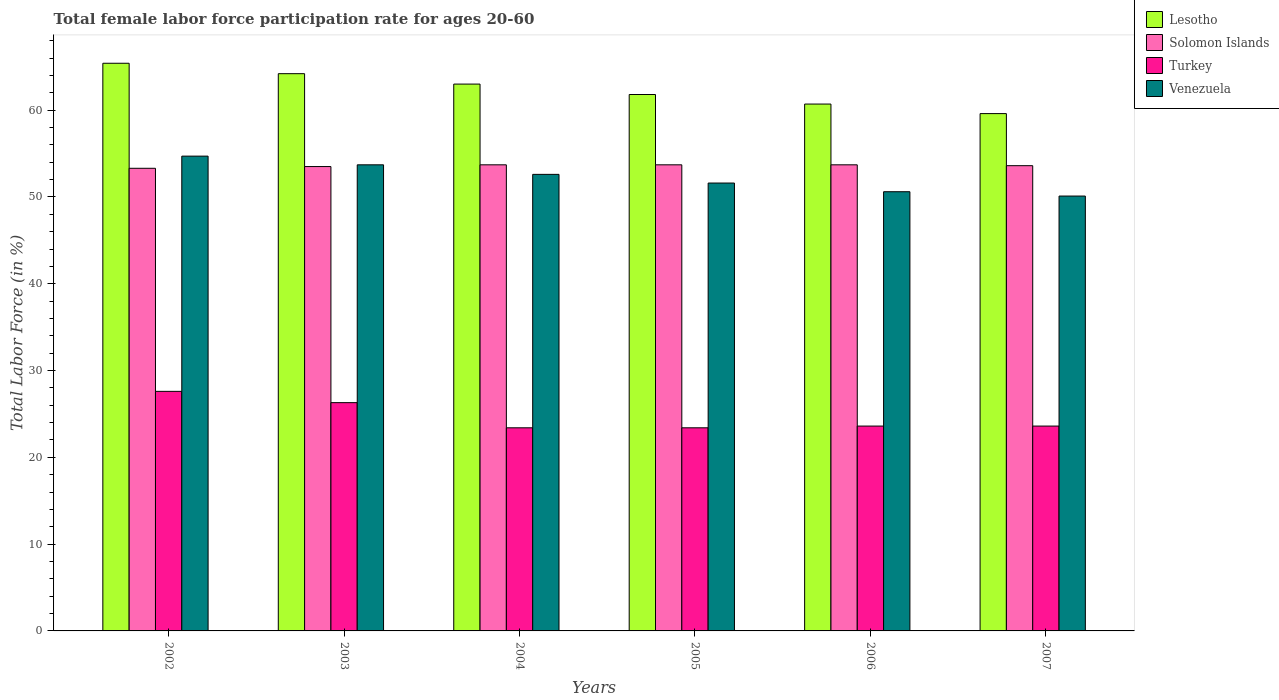How many different coloured bars are there?
Your answer should be compact. 4. How many groups of bars are there?
Offer a very short reply. 6. How many bars are there on the 2nd tick from the right?
Make the answer very short. 4. What is the label of the 2nd group of bars from the left?
Make the answer very short. 2003. What is the female labor force participation rate in Solomon Islands in 2005?
Offer a very short reply. 53.7. Across all years, what is the maximum female labor force participation rate in Turkey?
Make the answer very short. 27.6. Across all years, what is the minimum female labor force participation rate in Venezuela?
Make the answer very short. 50.1. In which year was the female labor force participation rate in Venezuela maximum?
Your answer should be compact. 2002. In which year was the female labor force participation rate in Solomon Islands minimum?
Your answer should be compact. 2002. What is the total female labor force participation rate in Venezuela in the graph?
Provide a succinct answer. 313.3. What is the difference between the female labor force participation rate in Lesotho in 2004 and that in 2005?
Keep it short and to the point. 1.2. What is the difference between the female labor force participation rate in Turkey in 2005 and the female labor force participation rate in Lesotho in 2006?
Your answer should be very brief. -37.3. What is the average female labor force participation rate in Solomon Islands per year?
Ensure brevity in your answer.  53.58. In the year 2005, what is the difference between the female labor force participation rate in Venezuela and female labor force participation rate in Lesotho?
Offer a terse response. -10.2. What is the ratio of the female labor force participation rate in Lesotho in 2004 to that in 2005?
Your response must be concise. 1.02. Is the female labor force participation rate in Turkey in 2002 less than that in 2006?
Make the answer very short. No. Is the difference between the female labor force participation rate in Venezuela in 2004 and 2006 greater than the difference between the female labor force participation rate in Lesotho in 2004 and 2006?
Offer a terse response. No. What is the difference between the highest and the second highest female labor force participation rate in Lesotho?
Your answer should be compact. 1.2. What is the difference between the highest and the lowest female labor force participation rate in Solomon Islands?
Your answer should be compact. 0.4. In how many years, is the female labor force participation rate in Lesotho greater than the average female labor force participation rate in Lesotho taken over all years?
Provide a short and direct response. 3. Is the sum of the female labor force participation rate in Turkey in 2002 and 2003 greater than the maximum female labor force participation rate in Solomon Islands across all years?
Give a very brief answer. Yes. Is it the case that in every year, the sum of the female labor force participation rate in Solomon Islands and female labor force participation rate in Lesotho is greater than the sum of female labor force participation rate in Turkey and female labor force participation rate in Venezuela?
Provide a short and direct response. No. What does the 2nd bar from the left in 2003 represents?
Your response must be concise. Solomon Islands. What does the 1st bar from the right in 2002 represents?
Keep it short and to the point. Venezuela. Are all the bars in the graph horizontal?
Offer a terse response. No. What is the difference between two consecutive major ticks on the Y-axis?
Keep it short and to the point. 10. Are the values on the major ticks of Y-axis written in scientific E-notation?
Keep it short and to the point. No. Does the graph contain any zero values?
Make the answer very short. No. Does the graph contain grids?
Offer a terse response. No. Where does the legend appear in the graph?
Offer a very short reply. Top right. How are the legend labels stacked?
Your answer should be very brief. Vertical. What is the title of the graph?
Provide a succinct answer. Total female labor force participation rate for ages 20-60. What is the Total Labor Force (in %) of Lesotho in 2002?
Ensure brevity in your answer.  65.4. What is the Total Labor Force (in %) of Solomon Islands in 2002?
Ensure brevity in your answer.  53.3. What is the Total Labor Force (in %) of Turkey in 2002?
Your response must be concise. 27.6. What is the Total Labor Force (in %) in Venezuela in 2002?
Offer a terse response. 54.7. What is the Total Labor Force (in %) in Lesotho in 2003?
Your answer should be very brief. 64.2. What is the Total Labor Force (in %) of Solomon Islands in 2003?
Offer a terse response. 53.5. What is the Total Labor Force (in %) in Turkey in 2003?
Offer a terse response. 26.3. What is the Total Labor Force (in %) in Venezuela in 2003?
Make the answer very short. 53.7. What is the Total Labor Force (in %) of Solomon Islands in 2004?
Provide a succinct answer. 53.7. What is the Total Labor Force (in %) of Turkey in 2004?
Ensure brevity in your answer.  23.4. What is the Total Labor Force (in %) in Venezuela in 2004?
Keep it short and to the point. 52.6. What is the Total Labor Force (in %) of Lesotho in 2005?
Provide a short and direct response. 61.8. What is the Total Labor Force (in %) in Solomon Islands in 2005?
Provide a succinct answer. 53.7. What is the Total Labor Force (in %) of Turkey in 2005?
Provide a succinct answer. 23.4. What is the Total Labor Force (in %) of Venezuela in 2005?
Keep it short and to the point. 51.6. What is the Total Labor Force (in %) in Lesotho in 2006?
Offer a very short reply. 60.7. What is the Total Labor Force (in %) in Solomon Islands in 2006?
Make the answer very short. 53.7. What is the Total Labor Force (in %) of Turkey in 2006?
Offer a very short reply. 23.6. What is the Total Labor Force (in %) in Venezuela in 2006?
Provide a short and direct response. 50.6. What is the Total Labor Force (in %) in Lesotho in 2007?
Keep it short and to the point. 59.6. What is the Total Labor Force (in %) of Solomon Islands in 2007?
Offer a terse response. 53.6. What is the Total Labor Force (in %) in Turkey in 2007?
Keep it short and to the point. 23.6. What is the Total Labor Force (in %) in Venezuela in 2007?
Provide a succinct answer. 50.1. Across all years, what is the maximum Total Labor Force (in %) in Lesotho?
Provide a succinct answer. 65.4. Across all years, what is the maximum Total Labor Force (in %) in Solomon Islands?
Give a very brief answer. 53.7. Across all years, what is the maximum Total Labor Force (in %) of Turkey?
Keep it short and to the point. 27.6. Across all years, what is the maximum Total Labor Force (in %) of Venezuela?
Keep it short and to the point. 54.7. Across all years, what is the minimum Total Labor Force (in %) in Lesotho?
Offer a terse response. 59.6. Across all years, what is the minimum Total Labor Force (in %) of Solomon Islands?
Offer a very short reply. 53.3. Across all years, what is the minimum Total Labor Force (in %) of Turkey?
Your response must be concise. 23.4. Across all years, what is the minimum Total Labor Force (in %) of Venezuela?
Offer a terse response. 50.1. What is the total Total Labor Force (in %) in Lesotho in the graph?
Offer a very short reply. 374.7. What is the total Total Labor Force (in %) of Solomon Islands in the graph?
Offer a very short reply. 321.5. What is the total Total Labor Force (in %) of Turkey in the graph?
Give a very brief answer. 147.9. What is the total Total Labor Force (in %) of Venezuela in the graph?
Keep it short and to the point. 313.3. What is the difference between the Total Labor Force (in %) of Lesotho in 2002 and that in 2003?
Make the answer very short. 1.2. What is the difference between the Total Labor Force (in %) of Lesotho in 2002 and that in 2004?
Offer a very short reply. 2.4. What is the difference between the Total Labor Force (in %) in Solomon Islands in 2002 and that in 2004?
Make the answer very short. -0.4. What is the difference between the Total Labor Force (in %) of Turkey in 2002 and that in 2004?
Offer a very short reply. 4.2. What is the difference between the Total Labor Force (in %) in Solomon Islands in 2002 and that in 2005?
Ensure brevity in your answer.  -0.4. What is the difference between the Total Labor Force (in %) in Lesotho in 2002 and that in 2006?
Give a very brief answer. 4.7. What is the difference between the Total Labor Force (in %) of Solomon Islands in 2002 and that in 2006?
Offer a terse response. -0.4. What is the difference between the Total Labor Force (in %) of Venezuela in 2002 and that in 2006?
Your response must be concise. 4.1. What is the difference between the Total Labor Force (in %) of Lesotho in 2002 and that in 2007?
Offer a very short reply. 5.8. What is the difference between the Total Labor Force (in %) in Solomon Islands in 2003 and that in 2004?
Give a very brief answer. -0.2. What is the difference between the Total Labor Force (in %) in Turkey in 2003 and that in 2004?
Make the answer very short. 2.9. What is the difference between the Total Labor Force (in %) in Venezuela in 2003 and that in 2004?
Give a very brief answer. 1.1. What is the difference between the Total Labor Force (in %) in Lesotho in 2003 and that in 2005?
Make the answer very short. 2.4. What is the difference between the Total Labor Force (in %) in Turkey in 2003 and that in 2006?
Provide a short and direct response. 2.7. What is the difference between the Total Labor Force (in %) of Solomon Islands in 2003 and that in 2007?
Keep it short and to the point. -0.1. What is the difference between the Total Labor Force (in %) in Venezuela in 2003 and that in 2007?
Provide a short and direct response. 3.6. What is the difference between the Total Labor Force (in %) in Turkey in 2004 and that in 2005?
Offer a very short reply. 0. What is the difference between the Total Labor Force (in %) in Solomon Islands in 2004 and that in 2006?
Offer a terse response. 0. What is the difference between the Total Labor Force (in %) in Turkey in 2004 and that in 2006?
Ensure brevity in your answer.  -0.2. What is the difference between the Total Labor Force (in %) of Venezuela in 2004 and that in 2007?
Your answer should be very brief. 2.5. What is the difference between the Total Labor Force (in %) in Lesotho in 2005 and that in 2006?
Provide a succinct answer. 1.1. What is the difference between the Total Labor Force (in %) in Turkey in 2005 and that in 2006?
Your answer should be very brief. -0.2. What is the difference between the Total Labor Force (in %) in Venezuela in 2005 and that in 2006?
Offer a terse response. 1. What is the difference between the Total Labor Force (in %) in Lesotho in 2005 and that in 2007?
Offer a terse response. 2.2. What is the difference between the Total Labor Force (in %) of Turkey in 2005 and that in 2007?
Keep it short and to the point. -0.2. What is the difference between the Total Labor Force (in %) of Venezuela in 2005 and that in 2007?
Your answer should be very brief. 1.5. What is the difference between the Total Labor Force (in %) of Lesotho in 2006 and that in 2007?
Give a very brief answer. 1.1. What is the difference between the Total Labor Force (in %) of Turkey in 2006 and that in 2007?
Provide a short and direct response. 0. What is the difference between the Total Labor Force (in %) of Venezuela in 2006 and that in 2007?
Offer a very short reply. 0.5. What is the difference between the Total Labor Force (in %) in Lesotho in 2002 and the Total Labor Force (in %) in Turkey in 2003?
Offer a terse response. 39.1. What is the difference between the Total Labor Force (in %) in Lesotho in 2002 and the Total Labor Force (in %) in Venezuela in 2003?
Ensure brevity in your answer.  11.7. What is the difference between the Total Labor Force (in %) of Solomon Islands in 2002 and the Total Labor Force (in %) of Turkey in 2003?
Your answer should be very brief. 27. What is the difference between the Total Labor Force (in %) of Solomon Islands in 2002 and the Total Labor Force (in %) of Venezuela in 2003?
Give a very brief answer. -0.4. What is the difference between the Total Labor Force (in %) of Turkey in 2002 and the Total Labor Force (in %) of Venezuela in 2003?
Provide a succinct answer. -26.1. What is the difference between the Total Labor Force (in %) of Solomon Islands in 2002 and the Total Labor Force (in %) of Turkey in 2004?
Make the answer very short. 29.9. What is the difference between the Total Labor Force (in %) of Solomon Islands in 2002 and the Total Labor Force (in %) of Venezuela in 2004?
Provide a short and direct response. 0.7. What is the difference between the Total Labor Force (in %) of Lesotho in 2002 and the Total Labor Force (in %) of Turkey in 2005?
Your response must be concise. 42. What is the difference between the Total Labor Force (in %) in Solomon Islands in 2002 and the Total Labor Force (in %) in Turkey in 2005?
Provide a succinct answer. 29.9. What is the difference between the Total Labor Force (in %) of Lesotho in 2002 and the Total Labor Force (in %) of Turkey in 2006?
Keep it short and to the point. 41.8. What is the difference between the Total Labor Force (in %) of Solomon Islands in 2002 and the Total Labor Force (in %) of Turkey in 2006?
Provide a succinct answer. 29.7. What is the difference between the Total Labor Force (in %) in Lesotho in 2002 and the Total Labor Force (in %) in Solomon Islands in 2007?
Make the answer very short. 11.8. What is the difference between the Total Labor Force (in %) of Lesotho in 2002 and the Total Labor Force (in %) of Turkey in 2007?
Offer a very short reply. 41.8. What is the difference between the Total Labor Force (in %) of Solomon Islands in 2002 and the Total Labor Force (in %) of Turkey in 2007?
Ensure brevity in your answer.  29.7. What is the difference between the Total Labor Force (in %) in Solomon Islands in 2002 and the Total Labor Force (in %) in Venezuela in 2007?
Ensure brevity in your answer.  3.2. What is the difference between the Total Labor Force (in %) of Turkey in 2002 and the Total Labor Force (in %) of Venezuela in 2007?
Your answer should be compact. -22.5. What is the difference between the Total Labor Force (in %) of Lesotho in 2003 and the Total Labor Force (in %) of Solomon Islands in 2004?
Your response must be concise. 10.5. What is the difference between the Total Labor Force (in %) in Lesotho in 2003 and the Total Labor Force (in %) in Turkey in 2004?
Your response must be concise. 40.8. What is the difference between the Total Labor Force (in %) of Solomon Islands in 2003 and the Total Labor Force (in %) of Turkey in 2004?
Offer a very short reply. 30.1. What is the difference between the Total Labor Force (in %) of Turkey in 2003 and the Total Labor Force (in %) of Venezuela in 2004?
Give a very brief answer. -26.3. What is the difference between the Total Labor Force (in %) in Lesotho in 2003 and the Total Labor Force (in %) in Turkey in 2005?
Ensure brevity in your answer.  40.8. What is the difference between the Total Labor Force (in %) in Lesotho in 2003 and the Total Labor Force (in %) in Venezuela in 2005?
Ensure brevity in your answer.  12.6. What is the difference between the Total Labor Force (in %) in Solomon Islands in 2003 and the Total Labor Force (in %) in Turkey in 2005?
Provide a succinct answer. 30.1. What is the difference between the Total Labor Force (in %) of Turkey in 2003 and the Total Labor Force (in %) of Venezuela in 2005?
Give a very brief answer. -25.3. What is the difference between the Total Labor Force (in %) of Lesotho in 2003 and the Total Labor Force (in %) of Solomon Islands in 2006?
Offer a very short reply. 10.5. What is the difference between the Total Labor Force (in %) of Lesotho in 2003 and the Total Labor Force (in %) of Turkey in 2006?
Provide a short and direct response. 40.6. What is the difference between the Total Labor Force (in %) in Solomon Islands in 2003 and the Total Labor Force (in %) in Turkey in 2006?
Offer a terse response. 29.9. What is the difference between the Total Labor Force (in %) in Solomon Islands in 2003 and the Total Labor Force (in %) in Venezuela in 2006?
Make the answer very short. 2.9. What is the difference between the Total Labor Force (in %) of Turkey in 2003 and the Total Labor Force (in %) of Venezuela in 2006?
Provide a short and direct response. -24.3. What is the difference between the Total Labor Force (in %) in Lesotho in 2003 and the Total Labor Force (in %) in Solomon Islands in 2007?
Give a very brief answer. 10.6. What is the difference between the Total Labor Force (in %) in Lesotho in 2003 and the Total Labor Force (in %) in Turkey in 2007?
Give a very brief answer. 40.6. What is the difference between the Total Labor Force (in %) of Lesotho in 2003 and the Total Labor Force (in %) of Venezuela in 2007?
Give a very brief answer. 14.1. What is the difference between the Total Labor Force (in %) of Solomon Islands in 2003 and the Total Labor Force (in %) of Turkey in 2007?
Give a very brief answer. 29.9. What is the difference between the Total Labor Force (in %) in Solomon Islands in 2003 and the Total Labor Force (in %) in Venezuela in 2007?
Give a very brief answer. 3.4. What is the difference between the Total Labor Force (in %) of Turkey in 2003 and the Total Labor Force (in %) of Venezuela in 2007?
Provide a succinct answer. -23.8. What is the difference between the Total Labor Force (in %) in Lesotho in 2004 and the Total Labor Force (in %) in Turkey in 2005?
Make the answer very short. 39.6. What is the difference between the Total Labor Force (in %) of Lesotho in 2004 and the Total Labor Force (in %) of Venezuela in 2005?
Make the answer very short. 11.4. What is the difference between the Total Labor Force (in %) in Solomon Islands in 2004 and the Total Labor Force (in %) in Turkey in 2005?
Make the answer very short. 30.3. What is the difference between the Total Labor Force (in %) of Solomon Islands in 2004 and the Total Labor Force (in %) of Venezuela in 2005?
Offer a very short reply. 2.1. What is the difference between the Total Labor Force (in %) in Turkey in 2004 and the Total Labor Force (in %) in Venezuela in 2005?
Offer a very short reply. -28.2. What is the difference between the Total Labor Force (in %) of Lesotho in 2004 and the Total Labor Force (in %) of Solomon Islands in 2006?
Your response must be concise. 9.3. What is the difference between the Total Labor Force (in %) of Lesotho in 2004 and the Total Labor Force (in %) of Turkey in 2006?
Offer a terse response. 39.4. What is the difference between the Total Labor Force (in %) in Solomon Islands in 2004 and the Total Labor Force (in %) in Turkey in 2006?
Offer a very short reply. 30.1. What is the difference between the Total Labor Force (in %) in Turkey in 2004 and the Total Labor Force (in %) in Venezuela in 2006?
Offer a terse response. -27.2. What is the difference between the Total Labor Force (in %) in Lesotho in 2004 and the Total Labor Force (in %) in Turkey in 2007?
Your response must be concise. 39.4. What is the difference between the Total Labor Force (in %) in Solomon Islands in 2004 and the Total Labor Force (in %) in Turkey in 2007?
Give a very brief answer. 30.1. What is the difference between the Total Labor Force (in %) in Turkey in 2004 and the Total Labor Force (in %) in Venezuela in 2007?
Your answer should be very brief. -26.7. What is the difference between the Total Labor Force (in %) of Lesotho in 2005 and the Total Labor Force (in %) of Turkey in 2006?
Give a very brief answer. 38.2. What is the difference between the Total Labor Force (in %) of Lesotho in 2005 and the Total Labor Force (in %) of Venezuela in 2006?
Keep it short and to the point. 11.2. What is the difference between the Total Labor Force (in %) in Solomon Islands in 2005 and the Total Labor Force (in %) in Turkey in 2006?
Provide a short and direct response. 30.1. What is the difference between the Total Labor Force (in %) in Turkey in 2005 and the Total Labor Force (in %) in Venezuela in 2006?
Give a very brief answer. -27.2. What is the difference between the Total Labor Force (in %) of Lesotho in 2005 and the Total Labor Force (in %) of Solomon Islands in 2007?
Your response must be concise. 8.2. What is the difference between the Total Labor Force (in %) in Lesotho in 2005 and the Total Labor Force (in %) in Turkey in 2007?
Keep it short and to the point. 38.2. What is the difference between the Total Labor Force (in %) in Lesotho in 2005 and the Total Labor Force (in %) in Venezuela in 2007?
Keep it short and to the point. 11.7. What is the difference between the Total Labor Force (in %) of Solomon Islands in 2005 and the Total Labor Force (in %) of Turkey in 2007?
Your response must be concise. 30.1. What is the difference between the Total Labor Force (in %) of Solomon Islands in 2005 and the Total Labor Force (in %) of Venezuela in 2007?
Your response must be concise. 3.6. What is the difference between the Total Labor Force (in %) of Turkey in 2005 and the Total Labor Force (in %) of Venezuela in 2007?
Provide a short and direct response. -26.7. What is the difference between the Total Labor Force (in %) in Lesotho in 2006 and the Total Labor Force (in %) in Solomon Islands in 2007?
Make the answer very short. 7.1. What is the difference between the Total Labor Force (in %) in Lesotho in 2006 and the Total Labor Force (in %) in Turkey in 2007?
Make the answer very short. 37.1. What is the difference between the Total Labor Force (in %) in Solomon Islands in 2006 and the Total Labor Force (in %) in Turkey in 2007?
Make the answer very short. 30.1. What is the difference between the Total Labor Force (in %) of Solomon Islands in 2006 and the Total Labor Force (in %) of Venezuela in 2007?
Provide a short and direct response. 3.6. What is the difference between the Total Labor Force (in %) in Turkey in 2006 and the Total Labor Force (in %) in Venezuela in 2007?
Make the answer very short. -26.5. What is the average Total Labor Force (in %) of Lesotho per year?
Offer a terse response. 62.45. What is the average Total Labor Force (in %) in Solomon Islands per year?
Provide a short and direct response. 53.58. What is the average Total Labor Force (in %) of Turkey per year?
Keep it short and to the point. 24.65. What is the average Total Labor Force (in %) in Venezuela per year?
Keep it short and to the point. 52.22. In the year 2002, what is the difference between the Total Labor Force (in %) in Lesotho and Total Labor Force (in %) in Solomon Islands?
Your answer should be very brief. 12.1. In the year 2002, what is the difference between the Total Labor Force (in %) of Lesotho and Total Labor Force (in %) of Turkey?
Your answer should be compact. 37.8. In the year 2002, what is the difference between the Total Labor Force (in %) in Solomon Islands and Total Labor Force (in %) in Turkey?
Provide a short and direct response. 25.7. In the year 2002, what is the difference between the Total Labor Force (in %) of Solomon Islands and Total Labor Force (in %) of Venezuela?
Offer a very short reply. -1.4. In the year 2002, what is the difference between the Total Labor Force (in %) of Turkey and Total Labor Force (in %) of Venezuela?
Your answer should be very brief. -27.1. In the year 2003, what is the difference between the Total Labor Force (in %) in Lesotho and Total Labor Force (in %) in Solomon Islands?
Offer a very short reply. 10.7. In the year 2003, what is the difference between the Total Labor Force (in %) in Lesotho and Total Labor Force (in %) in Turkey?
Offer a terse response. 37.9. In the year 2003, what is the difference between the Total Labor Force (in %) of Solomon Islands and Total Labor Force (in %) of Turkey?
Your response must be concise. 27.2. In the year 2003, what is the difference between the Total Labor Force (in %) in Solomon Islands and Total Labor Force (in %) in Venezuela?
Your response must be concise. -0.2. In the year 2003, what is the difference between the Total Labor Force (in %) of Turkey and Total Labor Force (in %) of Venezuela?
Your answer should be very brief. -27.4. In the year 2004, what is the difference between the Total Labor Force (in %) in Lesotho and Total Labor Force (in %) in Solomon Islands?
Offer a terse response. 9.3. In the year 2004, what is the difference between the Total Labor Force (in %) of Lesotho and Total Labor Force (in %) of Turkey?
Ensure brevity in your answer.  39.6. In the year 2004, what is the difference between the Total Labor Force (in %) in Solomon Islands and Total Labor Force (in %) in Turkey?
Give a very brief answer. 30.3. In the year 2004, what is the difference between the Total Labor Force (in %) in Turkey and Total Labor Force (in %) in Venezuela?
Provide a succinct answer. -29.2. In the year 2005, what is the difference between the Total Labor Force (in %) in Lesotho and Total Labor Force (in %) in Solomon Islands?
Offer a very short reply. 8.1. In the year 2005, what is the difference between the Total Labor Force (in %) in Lesotho and Total Labor Force (in %) in Turkey?
Your answer should be very brief. 38.4. In the year 2005, what is the difference between the Total Labor Force (in %) of Lesotho and Total Labor Force (in %) of Venezuela?
Provide a succinct answer. 10.2. In the year 2005, what is the difference between the Total Labor Force (in %) of Solomon Islands and Total Labor Force (in %) of Turkey?
Provide a succinct answer. 30.3. In the year 2005, what is the difference between the Total Labor Force (in %) in Solomon Islands and Total Labor Force (in %) in Venezuela?
Offer a terse response. 2.1. In the year 2005, what is the difference between the Total Labor Force (in %) of Turkey and Total Labor Force (in %) of Venezuela?
Offer a very short reply. -28.2. In the year 2006, what is the difference between the Total Labor Force (in %) in Lesotho and Total Labor Force (in %) in Solomon Islands?
Offer a terse response. 7. In the year 2006, what is the difference between the Total Labor Force (in %) in Lesotho and Total Labor Force (in %) in Turkey?
Your answer should be compact. 37.1. In the year 2006, what is the difference between the Total Labor Force (in %) of Solomon Islands and Total Labor Force (in %) of Turkey?
Keep it short and to the point. 30.1. In the year 2006, what is the difference between the Total Labor Force (in %) in Solomon Islands and Total Labor Force (in %) in Venezuela?
Give a very brief answer. 3.1. In the year 2007, what is the difference between the Total Labor Force (in %) in Lesotho and Total Labor Force (in %) in Solomon Islands?
Keep it short and to the point. 6. In the year 2007, what is the difference between the Total Labor Force (in %) of Lesotho and Total Labor Force (in %) of Turkey?
Offer a very short reply. 36. In the year 2007, what is the difference between the Total Labor Force (in %) in Turkey and Total Labor Force (in %) in Venezuela?
Provide a succinct answer. -26.5. What is the ratio of the Total Labor Force (in %) in Lesotho in 2002 to that in 2003?
Offer a very short reply. 1.02. What is the ratio of the Total Labor Force (in %) in Solomon Islands in 2002 to that in 2003?
Make the answer very short. 1. What is the ratio of the Total Labor Force (in %) in Turkey in 2002 to that in 2003?
Provide a short and direct response. 1.05. What is the ratio of the Total Labor Force (in %) of Venezuela in 2002 to that in 2003?
Give a very brief answer. 1.02. What is the ratio of the Total Labor Force (in %) in Lesotho in 2002 to that in 2004?
Provide a succinct answer. 1.04. What is the ratio of the Total Labor Force (in %) in Solomon Islands in 2002 to that in 2004?
Offer a terse response. 0.99. What is the ratio of the Total Labor Force (in %) of Turkey in 2002 to that in 2004?
Give a very brief answer. 1.18. What is the ratio of the Total Labor Force (in %) of Venezuela in 2002 to that in 2004?
Offer a very short reply. 1.04. What is the ratio of the Total Labor Force (in %) in Lesotho in 2002 to that in 2005?
Your answer should be very brief. 1.06. What is the ratio of the Total Labor Force (in %) of Solomon Islands in 2002 to that in 2005?
Make the answer very short. 0.99. What is the ratio of the Total Labor Force (in %) of Turkey in 2002 to that in 2005?
Keep it short and to the point. 1.18. What is the ratio of the Total Labor Force (in %) of Venezuela in 2002 to that in 2005?
Your answer should be compact. 1.06. What is the ratio of the Total Labor Force (in %) in Lesotho in 2002 to that in 2006?
Provide a short and direct response. 1.08. What is the ratio of the Total Labor Force (in %) in Turkey in 2002 to that in 2006?
Provide a succinct answer. 1.17. What is the ratio of the Total Labor Force (in %) in Venezuela in 2002 to that in 2006?
Provide a succinct answer. 1.08. What is the ratio of the Total Labor Force (in %) in Lesotho in 2002 to that in 2007?
Your answer should be compact. 1.1. What is the ratio of the Total Labor Force (in %) of Solomon Islands in 2002 to that in 2007?
Offer a very short reply. 0.99. What is the ratio of the Total Labor Force (in %) in Turkey in 2002 to that in 2007?
Make the answer very short. 1.17. What is the ratio of the Total Labor Force (in %) in Venezuela in 2002 to that in 2007?
Provide a succinct answer. 1.09. What is the ratio of the Total Labor Force (in %) of Lesotho in 2003 to that in 2004?
Your answer should be compact. 1.02. What is the ratio of the Total Labor Force (in %) in Solomon Islands in 2003 to that in 2004?
Your answer should be very brief. 1. What is the ratio of the Total Labor Force (in %) in Turkey in 2003 to that in 2004?
Your answer should be very brief. 1.12. What is the ratio of the Total Labor Force (in %) in Venezuela in 2003 to that in 2004?
Your answer should be very brief. 1.02. What is the ratio of the Total Labor Force (in %) in Lesotho in 2003 to that in 2005?
Provide a short and direct response. 1.04. What is the ratio of the Total Labor Force (in %) of Turkey in 2003 to that in 2005?
Make the answer very short. 1.12. What is the ratio of the Total Labor Force (in %) in Venezuela in 2003 to that in 2005?
Keep it short and to the point. 1.04. What is the ratio of the Total Labor Force (in %) in Lesotho in 2003 to that in 2006?
Your response must be concise. 1.06. What is the ratio of the Total Labor Force (in %) in Solomon Islands in 2003 to that in 2006?
Offer a very short reply. 1. What is the ratio of the Total Labor Force (in %) in Turkey in 2003 to that in 2006?
Your answer should be compact. 1.11. What is the ratio of the Total Labor Force (in %) of Venezuela in 2003 to that in 2006?
Keep it short and to the point. 1.06. What is the ratio of the Total Labor Force (in %) in Lesotho in 2003 to that in 2007?
Your answer should be compact. 1.08. What is the ratio of the Total Labor Force (in %) in Solomon Islands in 2003 to that in 2007?
Provide a succinct answer. 1. What is the ratio of the Total Labor Force (in %) of Turkey in 2003 to that in 2007?
Your response must be concise. 1.11. What is the ratio of the Total Labor Force (in %) of Venezuela in 2003 to that in 2007?
Your answer should be compact. 1.07. What is the ratio of the Total Labor Force (in %) in Lesotho in 2004 to that in 2005?
Offer a very short reply. 1.02. What is the ratio of the Total Labor Force (in %) in Venezuela in 2004 to that in 2005?
Your answer should be compact. 1.02. What is the ratio of the Total Labor Force (in %) of Lesotho in 2004 to that in 2006?
Offer a terse response. 1.04. What is the ratio of the Total Labor Force (in %) in Solomon Islands in 2004 to that in 2006?
Ensure brevity in your answer.  1. What is the ratio of the Total Labor Force (in %) of Venezuela in 2004 to that in 2006?
Ensure brevity in your answer.  1.04. What is the ratio of the Total Labor Force (in %) of Lesotho in 2004 to that in 2007?
Keep it short and to the point. 1.06. What is the ratio of the Total Labor Force (in %) of Turkey in 2004 to that in 2007?
Provide a short and direct response. 0.99. What is the ratio of the Total Labor Force (in %) of Venezuela in 2004 to that in 2007?
Ensure brevity in your answer.  1.05. What is the ratio of the Total Labor Force (in %) in Lesotho in 2005 to that in 2006?
Give a very brief answer. 1.02. What is the ratio of the Total Labor Force (in %) of Venezuela in 2005 to that in 2006?
Give a very brief answer. 1.02. What is the ratio of the Total Labor Force (in %) of Lesotho in 2005 to that in 2007?
Provide a short and direct response. 1.04. What is the ratio of the Total Labor Force (in %) in Venezuela in 2005 to that in 2007?
Offer a very short reply. 1.03. What is the ratio of the Total Labor Force (in %) of Lesotho in 2006 to that in 2007?
Offer a very short reply. 1.02. What is the ratio of the Total Labor Force (in %) of Venezuela in 2006 to that in 2007?
Give a very brief answer. 1.01. What is the difference between the highest and the second highest Total Labor Force (in %) of Solomon Islands?
Give a very brief answer. 0. What is the difference between the highest and the second highest Total Labor Force (in %) in Turkey?
Your answer should be very brief. 1.3. What is the difference between the highest and the second highest Total Labor Force (in %) in Venezuela?
Offer a terse response. 1. What is the difference between the highest and the lowest Total Labor Force (in %) in Lesotho?
Offer a very short reply. 5.8. What is the difference between the highest and the lowest Total Labor Force (in %) in Solomon Islands?
Provide a succinct answer. 0.4. What is the difference between the highest and the lowest Total Labor Force (in %) of Turkey?
Ensure brevity in your answer.  4.2. 